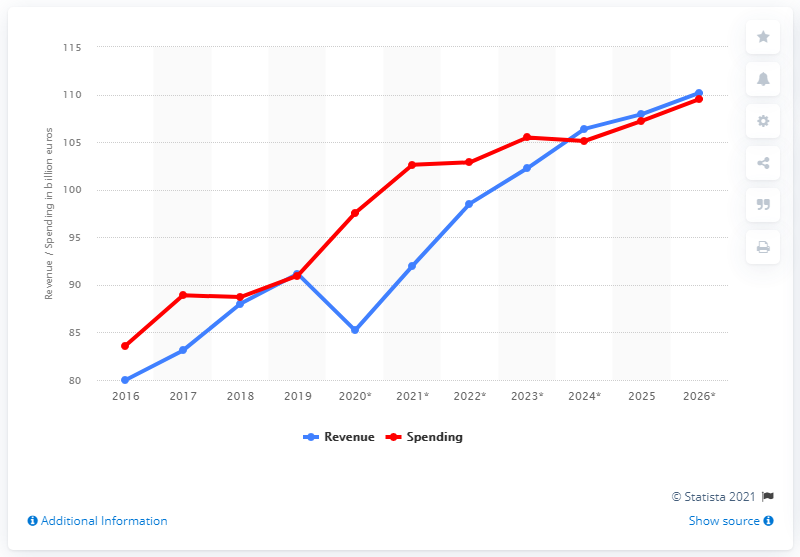List a handful of essential elements in this visual. In 2019, the government spent 91.16% of the total budget allocated to it in Portugal. In 2019, the government revenue in Portugal was approximately 91.99. 